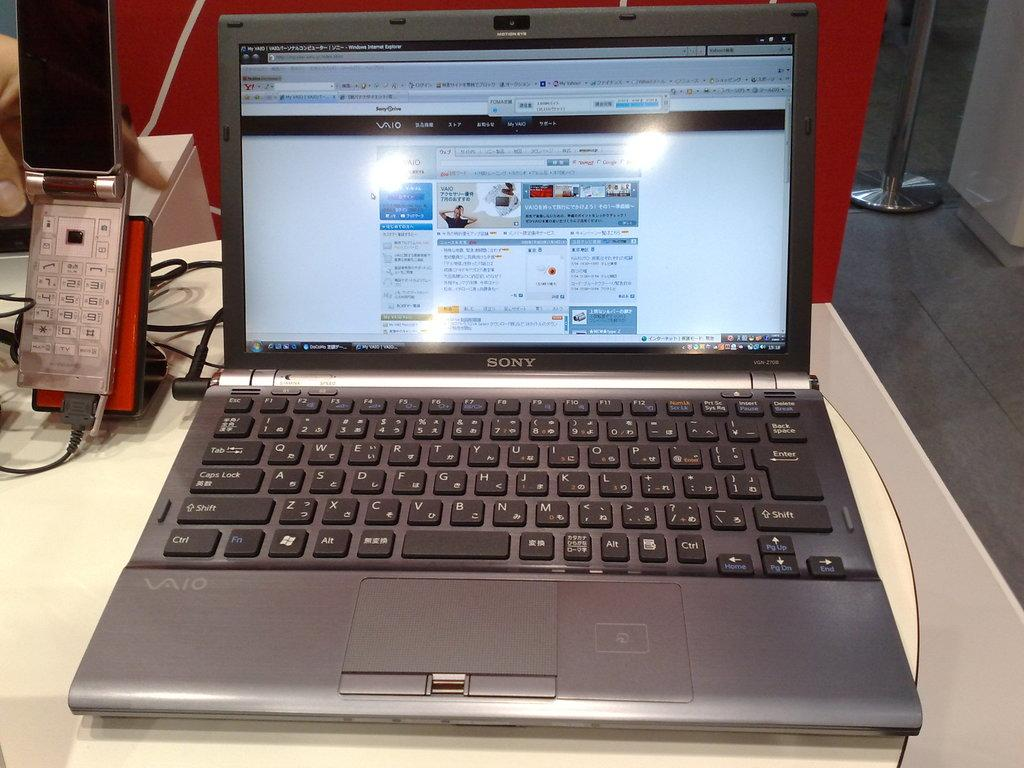<image>
Present a compact description of the photo's key features. a Sony lap top computer open to a colorful screen 